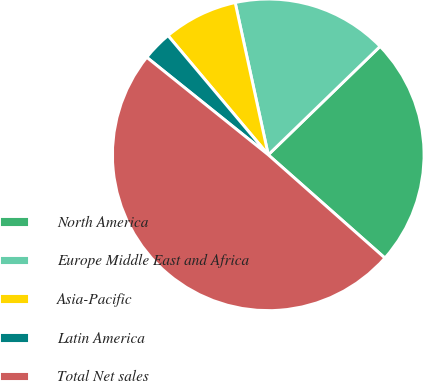<chart> <loc_0><loc_0><loc_500><loc_500><pie_chart><fcel>North America<fcel>Europe Middle East and Africa<fcel>Asia-Pacific<fcel>Latin America<fcel>Total Net sales<nl><fcel>23.78%<fcel>16.15%<fcel>7.72%<fcel>3.11%<fcel>49.23%<nl></chart> 